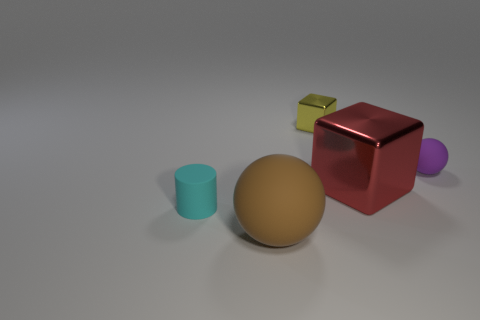Add 4 small matte balls. How many objects exist? 9 Subtract all cylinders. How many objects are left? 4 Add 2 small yellow objects. How many small yellow objects are left? 3 Add 2 tiny red blocks. How many tiny red blocks exist? 2 Subtract 1 cyan cylinders. How many objects are left? 4 Subtract all shiny things. Subtract all small cyan cylinders. How many objects are left? 2 